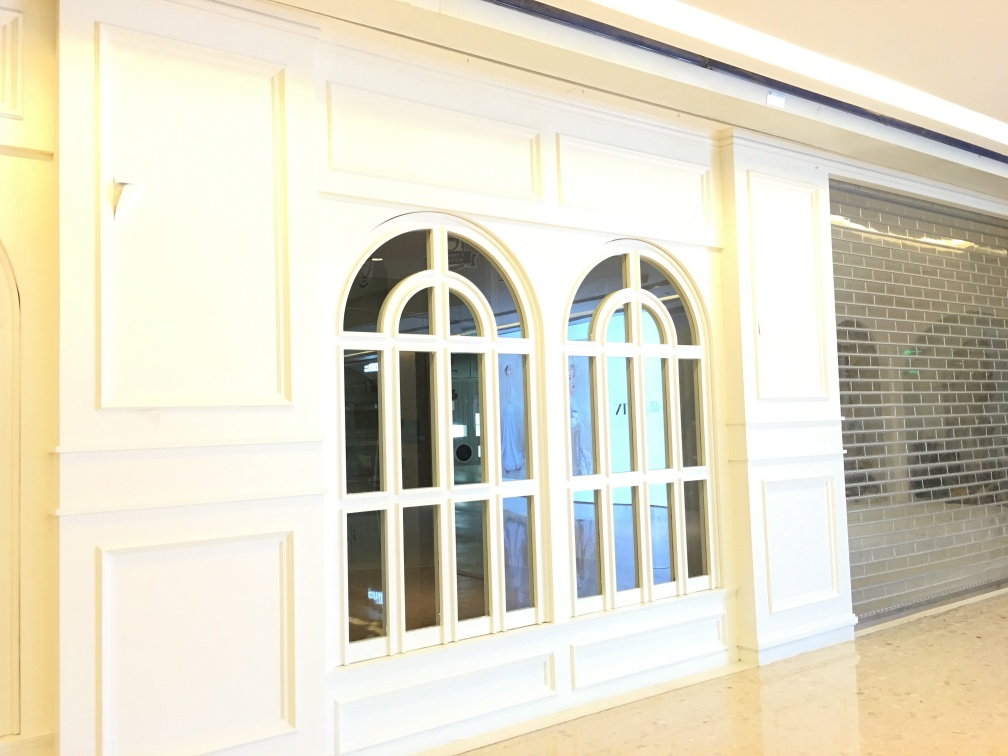How are the texture details of the architectural subject? The texture details of the architectural subject, which include the wall surfaces, window frames, and tiled floor, are preserved adequately. There is clarity in observing the individual tiles on the floor, the grain and texture of the masonry blocks next to the windows, and the smooth finish of the painted woodwork around the windows. While there is no significant enhancement to the textures, they are depicted with enough definition to appreciate the materials and craftsmanship. 